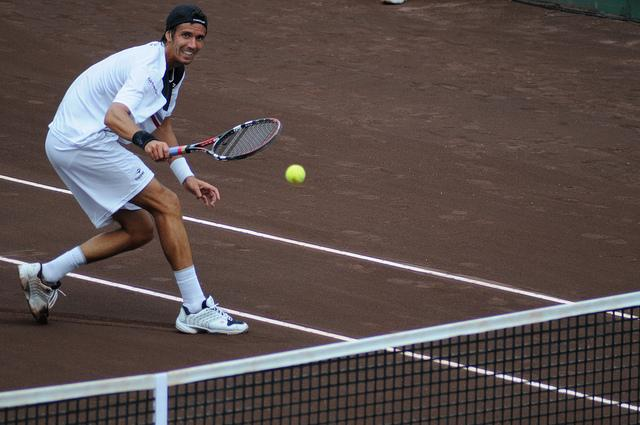How is the tennis player feeling? happy 